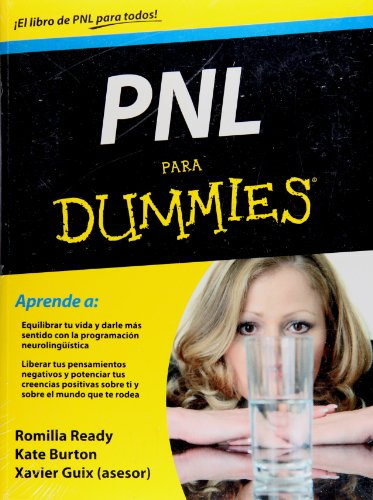Who is the author of this book?
Answer the question using a single word or phrase. Kate Burton What is the title of this book? PNL para Dummies (Spanish Edition) What is the genre of this book? Self-Help Is this a motivational book? Yes Is this a kids book? No 